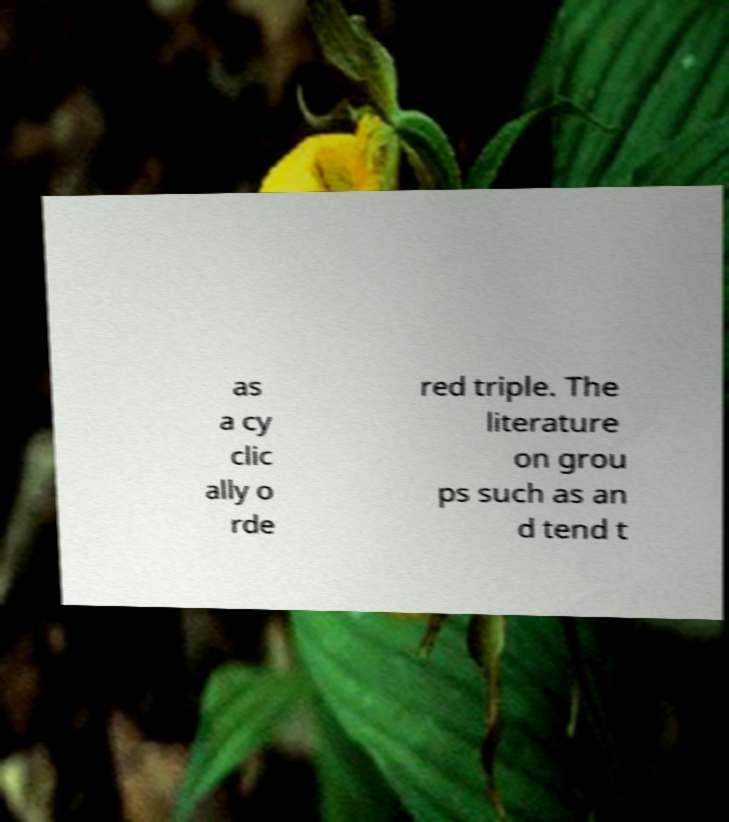I need the written content from this picture converted into text. Can you do that? as a cy clic ally o rde red triple. The literature on grou ps such as an d tend t 